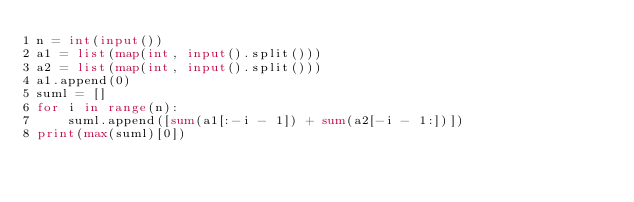Convert code to text. <code><loc_0><loc_0><loc_500><loc_500><_Python_>n = int(input())
a1 = list(map(int, input().split()))
a2 = list(map(int, input().split()))
a1.append(0)
suml = []
for i in range(n):
    suml.append([sum(a1[:-i - 1]) + sum(a2[-i - 1:])])
print(max(suml)[0])
</code> 